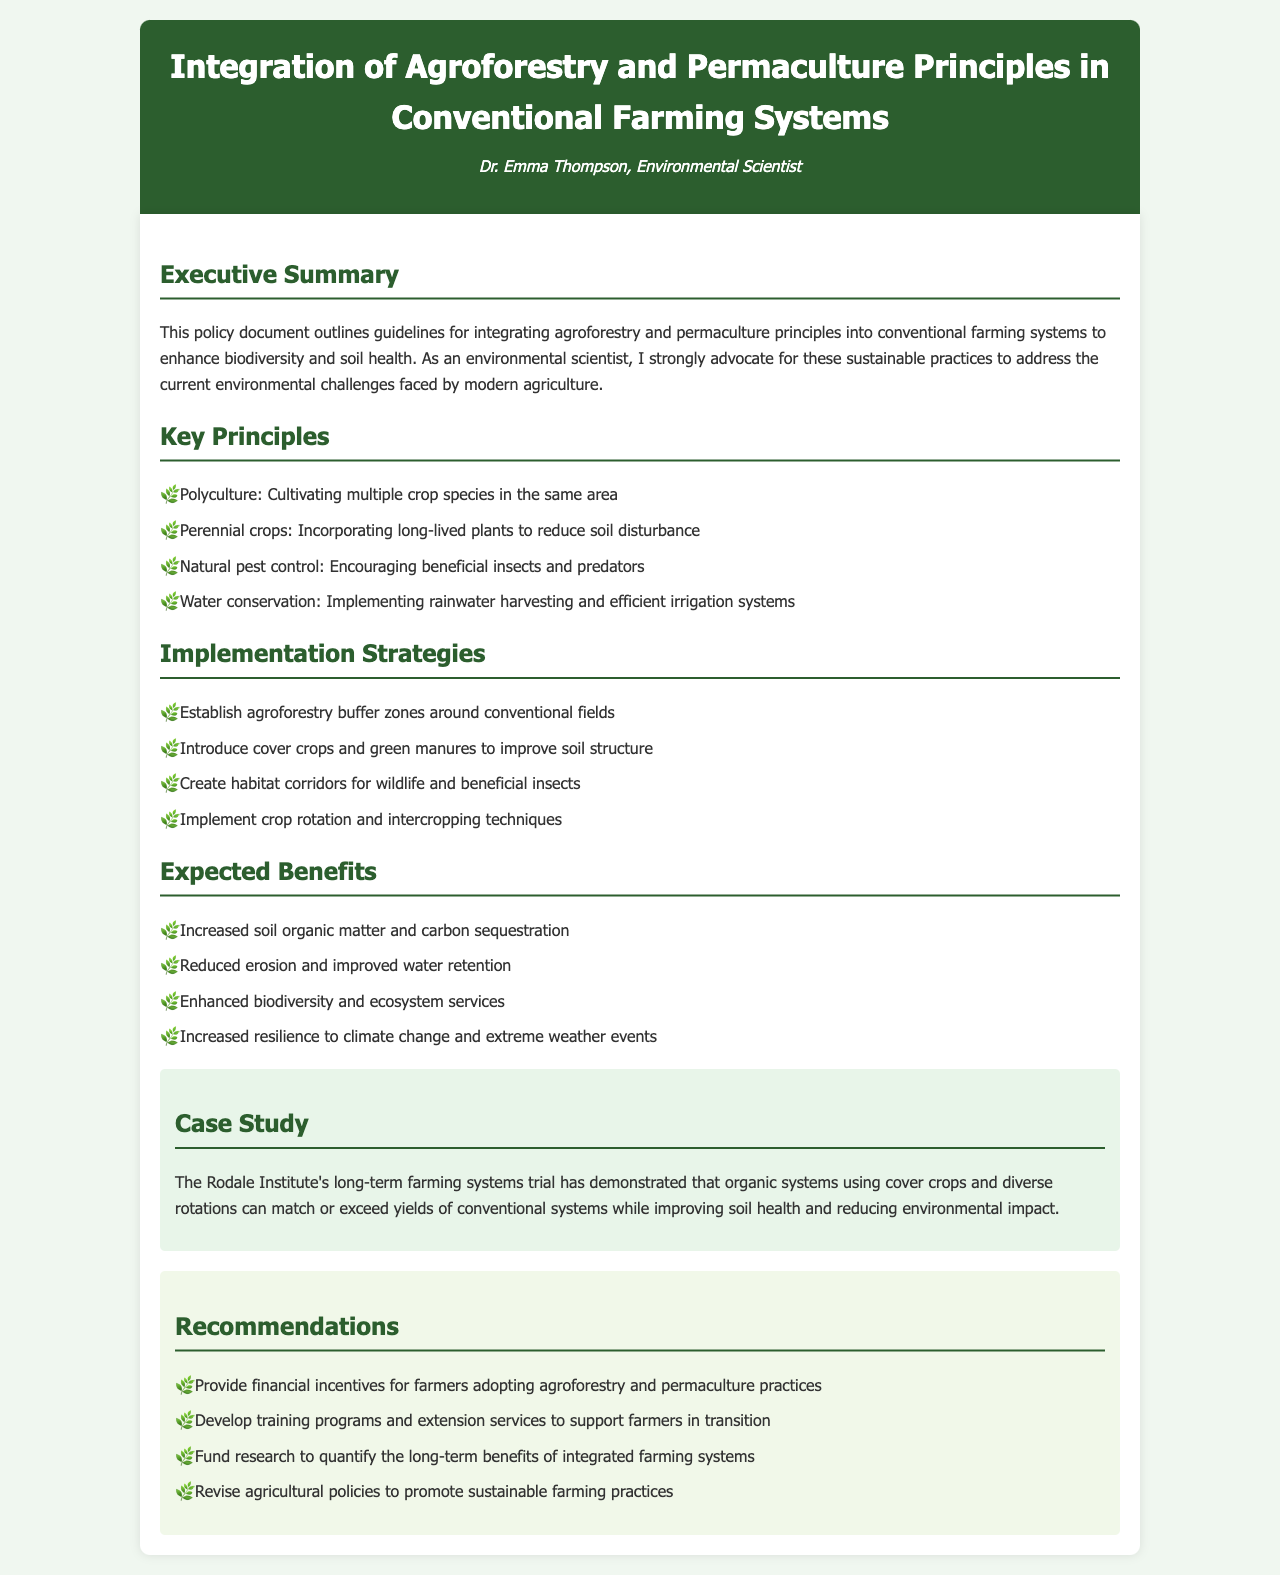What is the title of the document? The title is prominently displayed at the beginning of the document.
Answer: Integration of Agroforestry and Permaculture Principles in Conventional Farming Systems Who is the author of the document? The author's name is mentioned in the header section of the document.
Answer: Dr. Emma Thompson What are some key principles outlined in the document? Key principles are listed in the respective section, showcasing essential sustainable practices.
Answer: Polyculture, Perennial crops, Natural pest control, Water conservation What is one implementation strategy mentioned? Implementation strategies are listed in the relevant section focusing on practical steps.
Answer: Establish agroforestry buffer zones around conventional fields What is one expected benefit of integrating these principles? The expected benefits outline the positive impacts of the proposed practices as detailed in the document.
Answer: Increased soil organic matter and carbon sequestration What is the case study used in the document? The case study showcases a practical example of the benefits of the proposed practices and is noted in its own section.
Answer: The Rodale Institute's long-term farming systems trial What does the document recommend for farmers adopting these practices? The recommendations outline suggested actions to support farmers in transitioning to sustainable methods.
Answer: Provide financial incentives for farmers adopting agroforestry and permaculture practices How can research be funded according to the recommendations? The recommendations specifically mention funding avenues to enhance knowledge about integrated farming systems.
Answer: Fund research to quantify the long-term benefits of integrated farming systems What environmental challenge does the document aim to address? The executive summary highlights the key environmental issues that these guidelines seek to mitigate.
Answer: Current environmental challenges faced by modern agriculture 